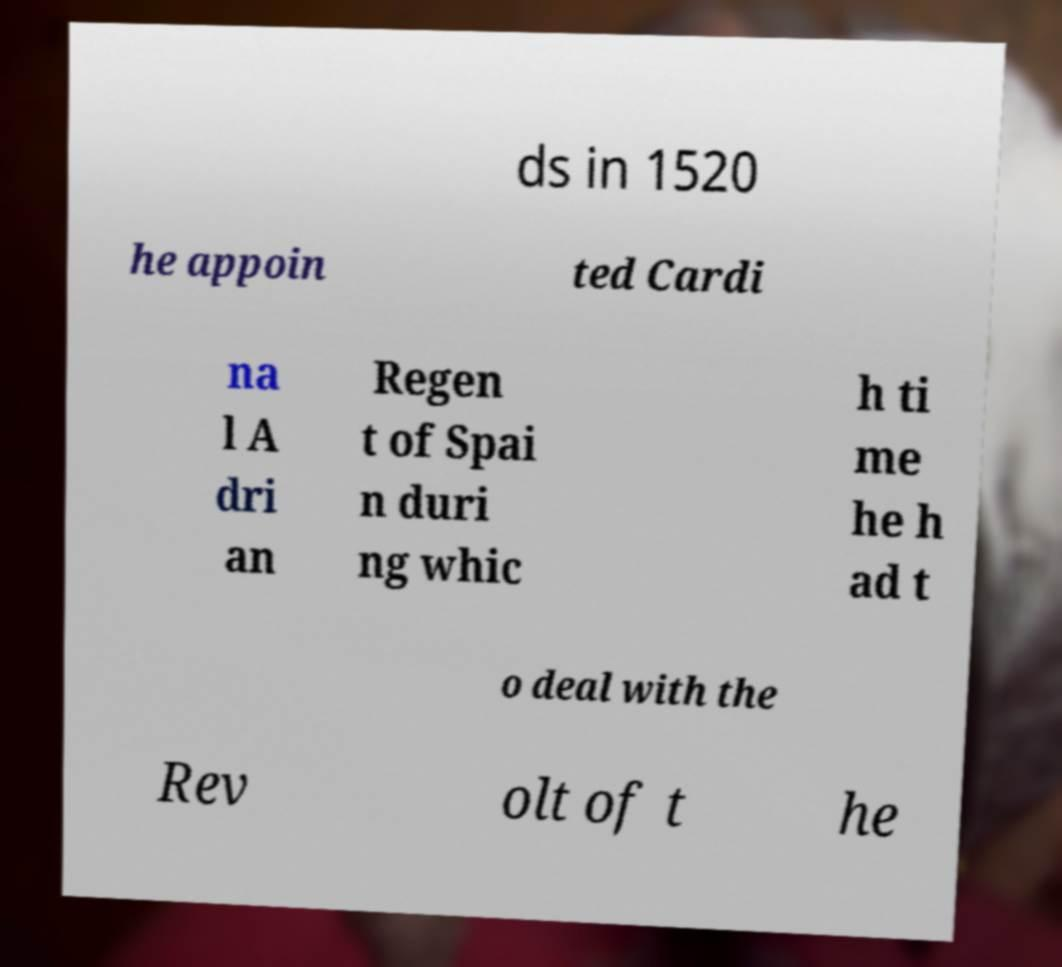Can you accurately transcribe the text from the provided image for me? ds in 1520 he appoin ted Cardi na l A dri an Regen t of Spai n duri ng whic h ti me he h ad t o deal with the Rev olt of t he 